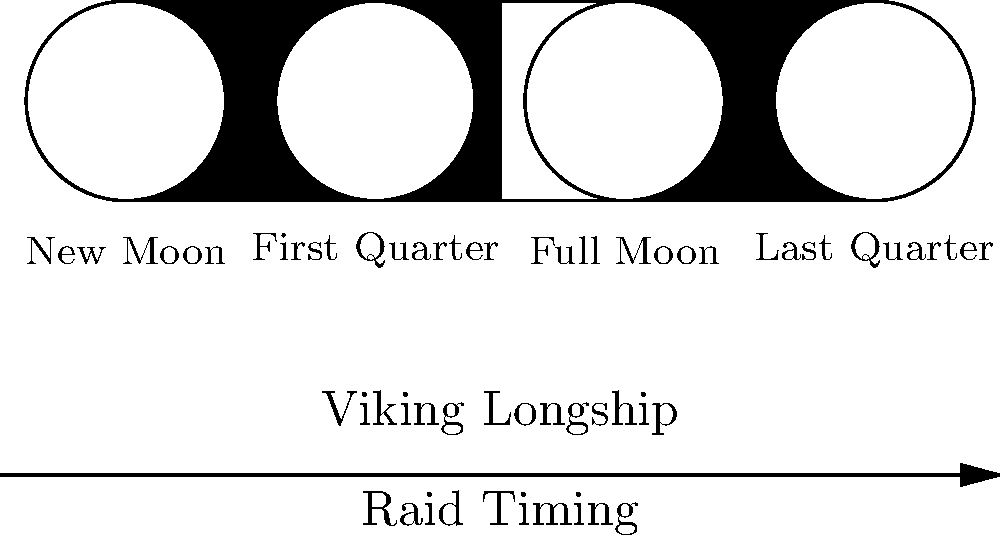Which phase of the moon would be most advantageous for a Viking raid, and why? To determine the most advantageous moon phase for a Viking raid, we need to consider several factors:

1. Visibility: Vikings relied on stealth for successful raids.
2. Navigation: The moon was crucial for nighttime navigation.
3. Tides: Moon phases affect tidal patterns, which impact ship movements.

Let's analyze each moon phase:

1. New Moon:
   - Pros: Darkest night, excellent for stealth.
   - Cons: Difficult navigation, potentially dangerous sailing conditions.

2. First Quarter:
   - Pros: Some light for navigation, moderate tides.
   - Cons: Partial visibility could compromise stealth.

3. Full Moon:
   - Pros: Excellent visibility for navigation, strongest tides.
   - Cons: Easiest for targets to spot approaching ships.

4. Last Quarter:
   - Pros: Moderate light for navigation, waning tides.
   - Cons: Some visibility, could affect stealth.

The new moon phase offers the best balance of stealth and manageable sailing conditions. While navigation is more challenging, Viking navigators were skilled enough to compensate. The darkness provides optimal cover for approaching coastlines undetected, a crucial element in Viking raid strategies.

The strong tides of the full moon, while beneficial for ship speed, would be outweighed by the increased risk of detection. First and last quarters provide compromises but lack the stealth advantage of the new moon.
Answer: New Moon phase 